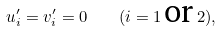Convert formula to latex. <formula><loc_0><loc_0><loc_500><loc_500>u ^ { \prime } _ { i } = v ^ { \prime } _ { i } = 0 \quad ( i = 1 \, \text {or} \, 2 ) ,</formula> 